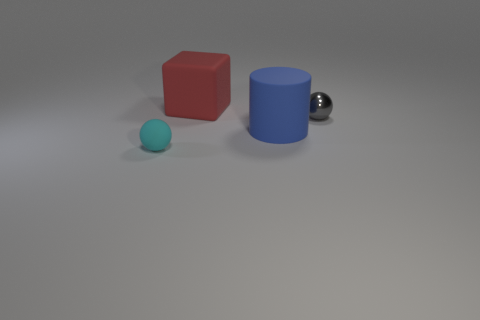Add 4 rubber things. How many objects exist? 8 Subtract all blocks. How many objects are left? 3 Subtract 0 purple cubes. How many objects are left? 4 Subtract all large cyan matte cubes. Subtract all metallic spheres. How many objects are left? 3 Add 2 large red blocks. How many large red blocks are left? 3 Add 4 red objects. How many red objects exist? 5 